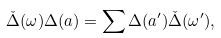<formula> <loc_0><loc_0><loc_500><loc_500>\check { \Delta } ( \omega ) \Delta ( a ) = \sum \Delta ( a ^ { \prime } ) \check { \Delta } ( \omega ^ { \prime } ) ,</formula> 